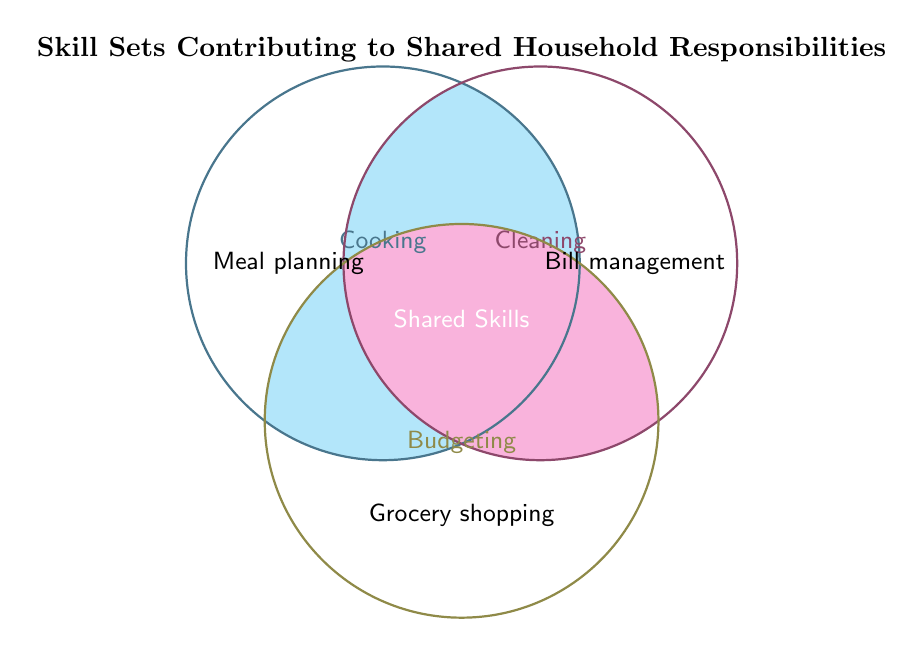What are the three skill sets shown in the Venn diagram? The three skill sets are labeled at the top of each circle.
Answer: Cooking, Cleaning, Budgeting Which two skill sets overlap to include "Meal planning"? In the Venn diagram, "Meal planning" is situated within the overlap area of Cooking and Cleaning.
Answer: Cooking, Cleaning Which household responsibility is associated with both Cleaning and Budgeting? In the Venn diagram, the intersection of Cleaning and Budgeting includes "Bill management."
Answer: Bill management How many skills are associated with all three areas: Cooking, Cleaning, and Budgeting? The shared skills area in the center of the Venn diagram does not name any new skill set, meaning there are no common skills across all three areas.
Answer: None What unique skill set is only found in the Budgeting circle? The unique skill set for the Budgeting circle is found outside of the overlaps with other circles and is "Grocery shopping."
Answer: Grocery shopping Are any skills shared between Cooking and Budgeting only? Check the area where Cooking and Budgeting overlap. There are no skills listed in that specific overlap area.
Answer: None How many total distinct skills are shown in the Venn diagram? Counting each skill listed in any part of the Venn diagram, we have six distinct skills: Meal planning, Bill management, Grocery shopping, Cooking, Cleaning, Budgeting.
Answer: Six Which skills are related to both Cooking and Cleaning? The skill set "Meal planning" is shown in the overlapping area of Cooking and Cleaning.
Answer: Meal planning If someone is good at both Cleaning and Budgeting, which skill could they help with in household responsibilities? The intersection of Cleaning and Budgeting in the Venn diagram includes "Bill management."
Answer: Bill management Which skill sets are shared between Cooking and Budgeting? According to the Venn diagram, no common skills are found in the intersection area between Cooking and Budgeting only.
Answer: None 